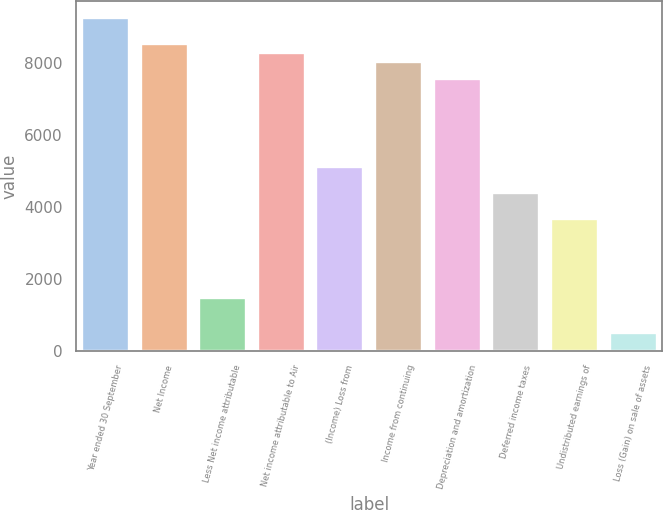Convert chart to OTSL. <chart><loc_0><loc_0><loc_500><loc_500><bar_chart><fcel>Year ended 30 September<fcel>Net Income<fcel>Less Net income attributable<fcel>Net income attributable to Air<fcel>(Income) Loss from<fcel>Income from continuing<fcel>Depreciation and amortization<fcel>Deferred income taxes<fcel>Undistributed earnings of<fcel>Loss (Gain) on sale of assets<nl><fcel>9250.12<fcel>8519.95<fcel>1461.64<fcel>8276.56<fcel>5112.49<fcel>8033.17<fcel>7546.39<fcel>4382.32<fcel>3652.15<fcel>488.08<nl></chart> 